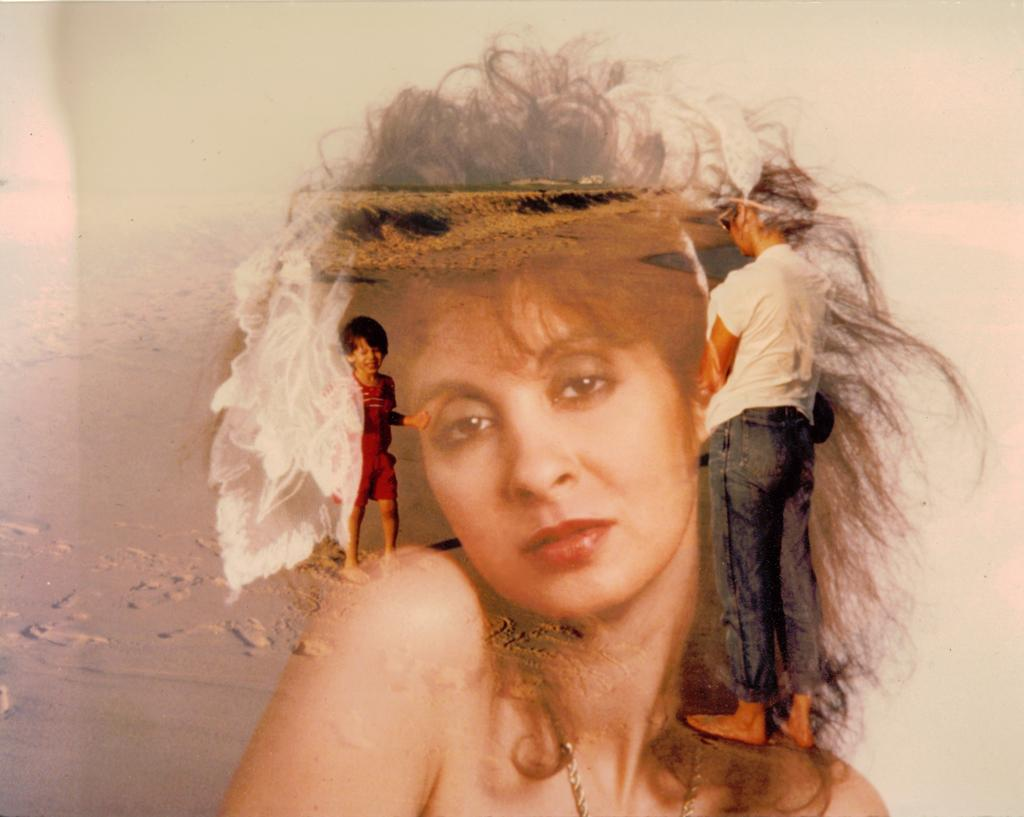Who is present in the image? There is a woman and a kid in the image. What are the woman and kid doing in the image? The woman and kid are playing in the background. What type of surface can be seen towards the left side of the image? There is sand visible towards the left side of the image. What type of muscle is visible on the woman's arm in the image? There is no muscle visible on the woman's arm in the image, as the focus is on the woman and kid playing and the sandy background. 